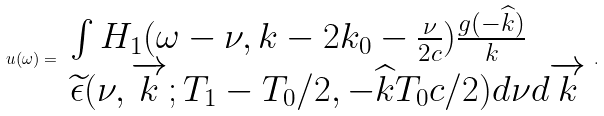<formula> <loc_0><loc_0><loc_500><loc_500>u ( \omega ) = \begin{array} [ t ] { l } \int H _ { 1 } ( \omega - \nu , k - 2 k _ { 0 } - \frac { \nu } { 2 c } ) \frac { g ( - \widehat { k } ) } { k } \\ \widetilde { \epsilon } ( \nu , \overrightarrow { k } ; T _ { 1 } - T _ { 0 } / 2 , - \widehat { k } T _ { 0 } c / 2 ) d \nu d \overrightarrow { k } \\ \end{array} .</formula> 